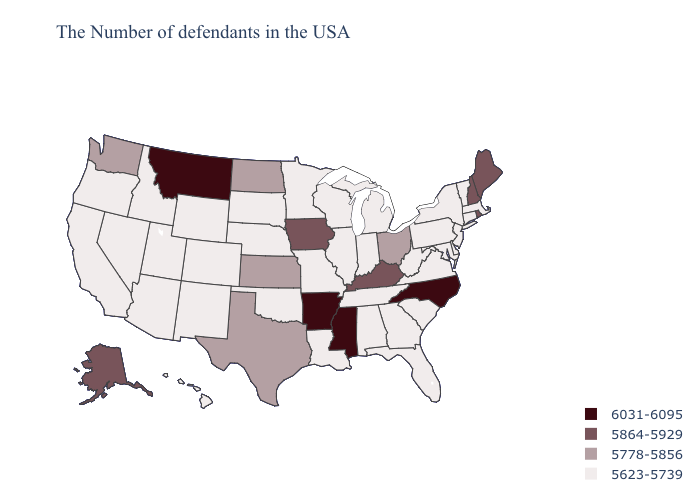What is the value of Illinois?
Give a very brief answer. 5623-5739. What is the value of South Carolina?
Quick response, please. 5623-5739. Does Arizona have the highest value in the USA?
Be succinct. No. Does the first symbol in the legend represent the smallest category?
Answer briefly. No. Does the map have missing data?
Give a very brief answer. No. Name the states that have a value in the range 5864-5929?
Give a very brief answer. Maine, Rhode Island, New Hampshire, Kentucky, Iowa, Alaska. Name the states that have a value in the range 5778-5856?
Quick response, please. Ohio, Kansas, Texas, North Dakota, Washington. Which states hav the highest value in the West?
Give a very brief answer. Montana. Name the states that have a value in the range 5623-5739?
Concise answer only. Massachusetts, Vermont, Connecticut, New York, New Jersey, Delaware, Maryland, Pennsylvania, Virginia, South Carolina, West Virginia, Florida, Georgia, Michigan, Indiana, Alabama, Tennessee, Wisconsin, Illinois, Louisiana, Missouri, Minnesota, Nebraska, Oklahoma, South Dakota, Wyoming, Colorado, New Mexico, Utah, Arizona, Idaho, Nevada, California, Oregon, Hawaii. Name the states that have a value in the range 6031-6095?
Short answer required. North Carolina, Mississippi, Arkansas, Montana. What is the value of Alabama?
Keep it brief. 5623-5739. Is the legend a continuous bar?
Short answer required. No. What is the highest value in states that border New Jersey?
Write a very short answer. 5623-5739. Does the first symbol in the legend represent the smallest category?
Quick response, please. No. Does New Mexico have the highest value in the West?
Answer briefly. No. 